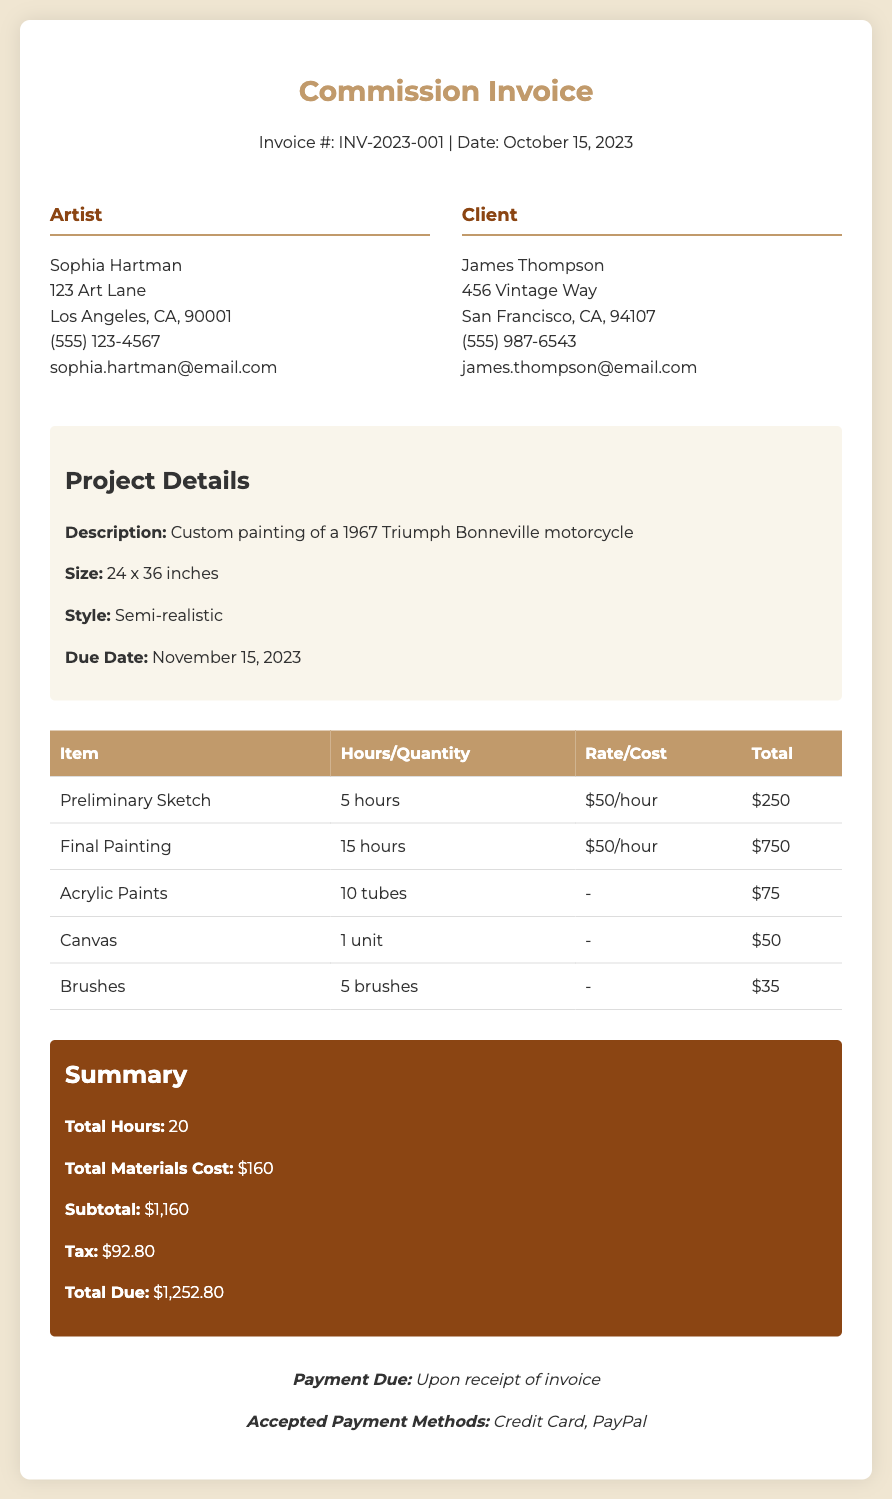What is the invoice number? The invoice number is indicated at the top of the document as "Invoice #: INV-2023-001".
Answer: INV-2023-001 What is the date of the invoice? The date of the invoice is specified next to the invoice number.
Answer: October 15, 2023 Who is the artist? The artist's name and details are listed in the info box under "Artist".
Answer: Sophia Hartman What is the total due amount? The total due is mentioned in the summary section as the final amount owed.
Answer: $1,252.80 How many hours were worked on the final painting? The hours for the final painting are provided in the table under the relevant item.
Answer: 15 hours What materials were used for the painting? The materials used are listed in the table with their corresponding costs.
Answer: Acrylic Paints, Canvas, Brushes What is the due date for the project? The due date is mentioned in the project details section.
Answer: November 15, 2023 What is the total number of hours worked? The total hours worked are summarized at the bottom of the invoice.
Answer: 20 What payment methods are accepted? Accepted payment methods are indicated in the payment terms section.
Answer: Credit Card, PayPal 